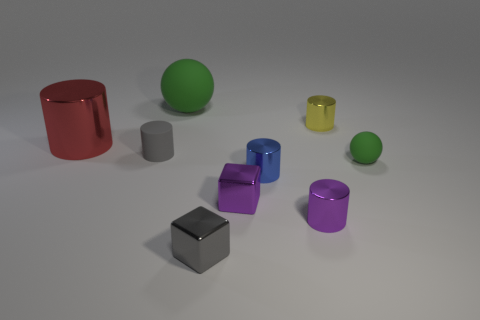What number of small gray things are the same shape as the blue shiny thing?
Your answer should be very brief. 1. How many small yellow metal objects are there?
Offer a terse response. 1. Does the green rubber object right of the yellow shiny cylinder have the same shape as the big green thing?
Your answer should be very brief. Yes. There is a green object that is the same size as the gray metallic thing; what is it made of?
Make the answer very short. Rubber. Is there another small cylinder that has the same material as the yellow cylinder?
Offer a terse response. Yes. Is the shape of the blue metallic object the same as the gray thing on the right side of the gray rubber object?
Provide a short and direct response. No. How many small things are both to the right of the gray metallic thing and in front of the tiny blue metal thing?
Keep it short and to the point. 2. Is the material of the tiny yellow cylinder the same as the ball that is on the right side of the tiny blue metallic thing?
Your answer should be very brief. No. Are there the same number of tiny blue metallic cylinders that are on the left side of the gray metal object and tiny brown metal balls?
Provide a succinct answer. Yes. The large object behind the red shiny cylinder is what color?
Your answer should be very brief. Green. 